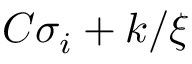Convert formula to latex. <formula><loc_0><loc_0><loc_500><loc_500>C \sigma _ { i } + k / \xi</formula> 